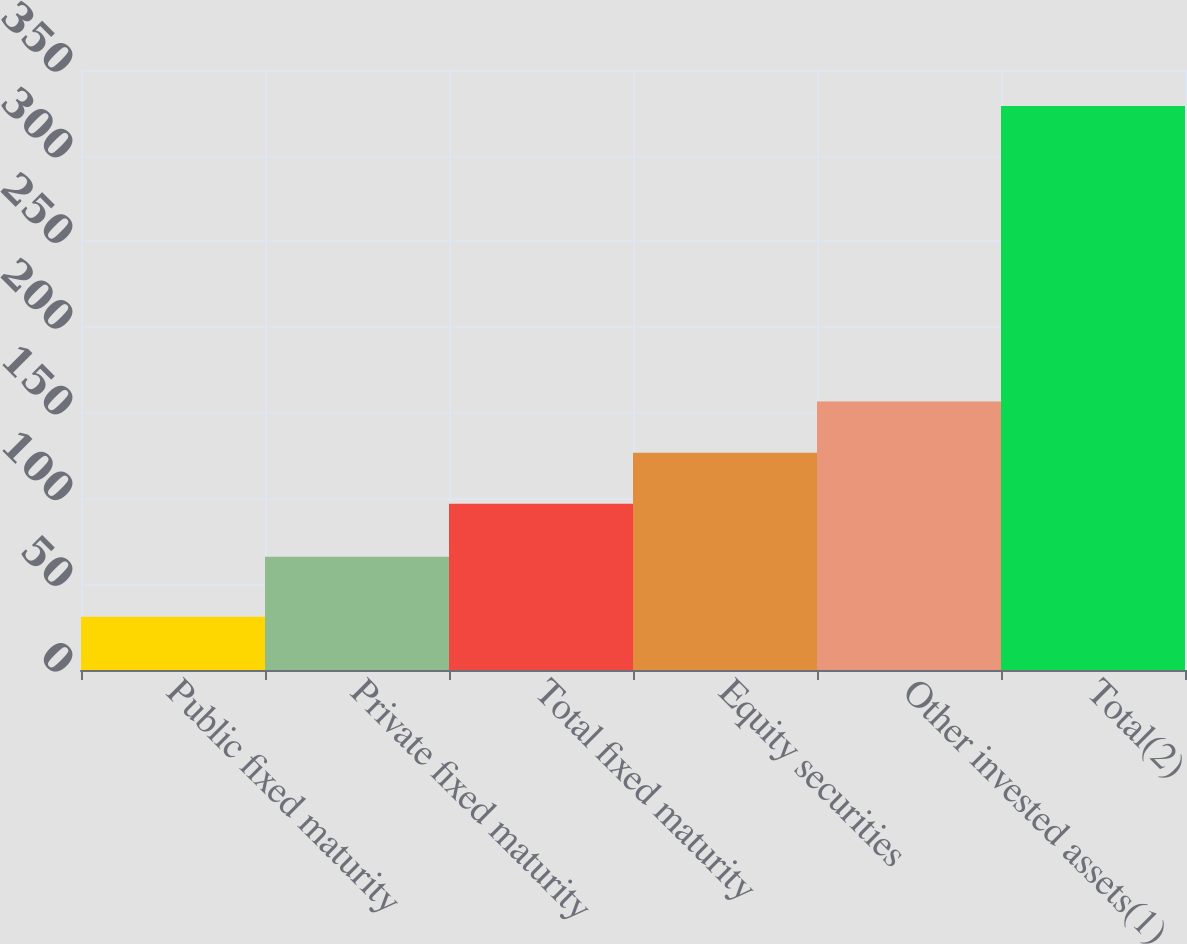<chart> <loc_0><loc_0><loc_500><loc_500><bar_chart><fcel>Public fixed maturity<fcel>Private fixed maturity<fcel>Total fixed maturity<fcel>Equity securities<fcel>Other invested assets(1)<fcel>Total(2)<nl><fcel>31<fcel>66<fcel>97<fcel>126.8<fcel>156.6<fcel>329<nl></chart> 